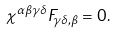<formula> <loc_0><loc_0><loc_500><loc_500>\chi ^ { \alpha \beta \gamma \delta } F _ { \gamma \delta , \beta } = 0 .</formula> 